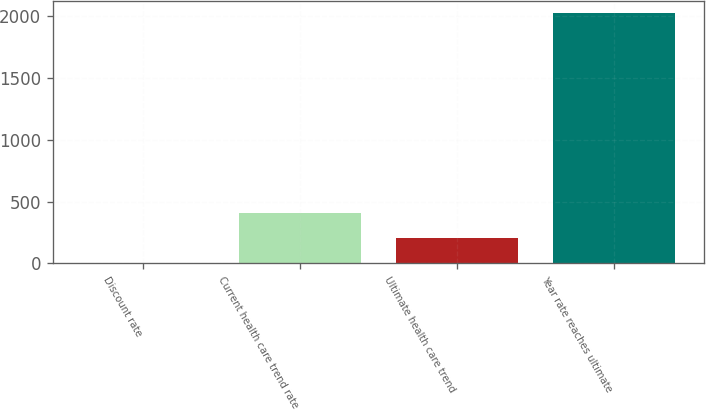<chart> <loc_0><loc_0><loc_500><loc_500><bar_chart><fcel>Discount rate<fcel>Current health care trend rate<fcel>Ultimate health care trend<fcel>Year rate reaches ultimate<nl><fcel>3.4<fcel>407.12<fcel>205.26<fcel>2022<nl></chart> 